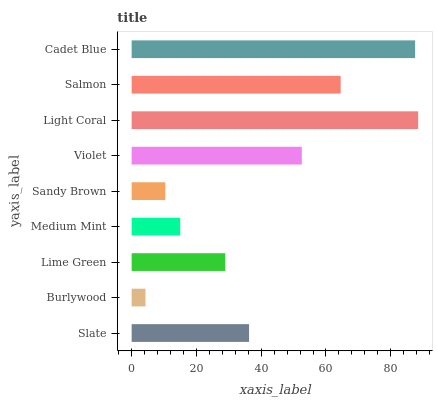Is Burlywood the minimum?
Answer yes or no. Yes. Is Light Coral the maximum?
Answer yes or no. Yes. Is Lime Green the minimum?
Answer yes or no. No. Is Lime Green the maximum?
Answer yes or no. No. Is Lime Green greater than Burlywood?
Answer yes or no. Yes. Is Burlywood less than Lime Green?
Answer yes or no. Yes. Is Burlywood greater than Lime Green?
Answer yes or no. No. Is Lime Green less than Burlywood?
Answer yes or no. No. Is Slate the high median?
Answer yes or no. Yes. Is Slate the low median?
Answer yes or no. Yes. Is Light Coral the high median?
Answer yes or no. No. Is Cadet Blue the low median?
Answer yes or no. No. 